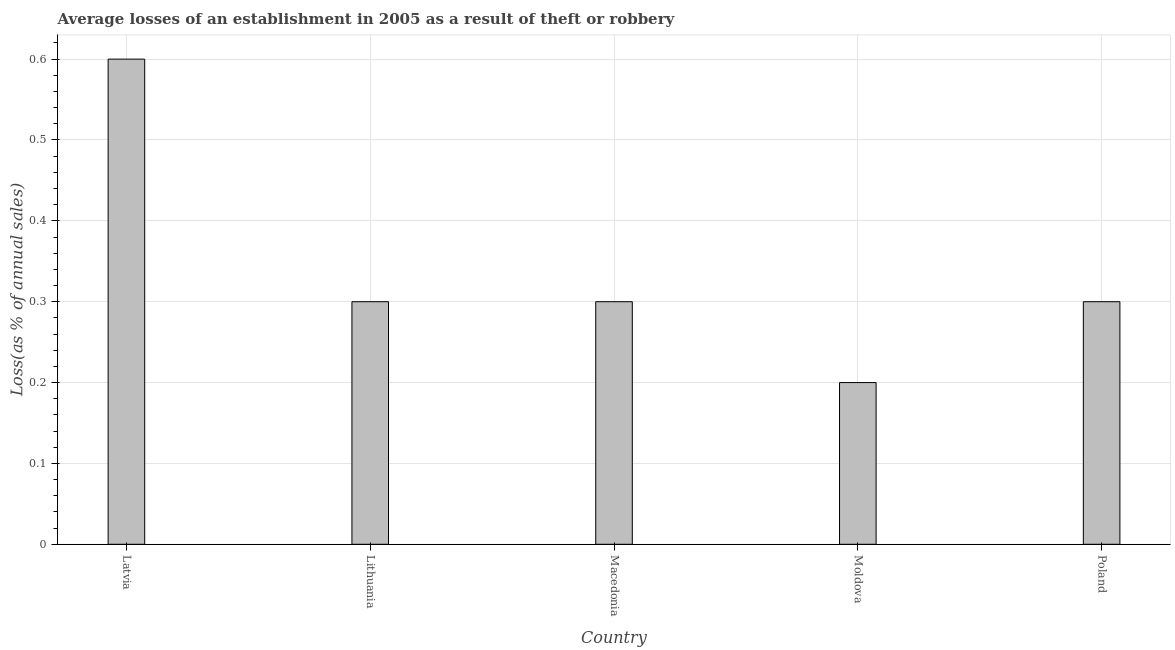Does the graph contain grids?
Your answer should be compact. Yes. What is the title of the graph?
Your response must be concise. Average losses of an establishment in 2005 as a result of theft or robbery. What is the label or title of the X-axis?
Your response must be concise. Country. What is the label or title of the Y-axis?
Offer a very short reply. Loss(as % of annual sales). Across all countries, what is the maximum losses due to theft?
Offer a terse response. 0.6. Across all countries, what is the minimum losses due to theft?
Your answer should be compact. 0.2. In which country was the losses due to theft maximum?
Make the answer very short. Latvia. In which country was the losses due to theft minimum?
Your answer should be very brief. Moldova. What is the average losses due to theft per country?
Offer a very short reply. 0.34. In how many countries, is the losses due to theft greater than 0.36 %?
Ensure brevity in your answer.  1. What is the ratio of the losses due to theft in Latvia to that in Moldova?
Ensure brevity in your answer.  3. What is the difference between the highest and the second highest losses due to theft?
Make the answer very short. 0.3. Is the sum of the losses due to theft in Latvia and Moldova greater than the maximum losses due to theft across all countries?
Give a very brief answer. Yes. What is the difference between the highest and the lowest losses due to theft?
Offer a very short reply. 0.4. In how many countries, is the losses due to theft greater than the average losses due to theft taken over all countries?
Offer a terse response. 1. Are all the bars in the graph horizontal?
Offer a terse response. No. How many countries are there in the graph?
Offer a very short reply. 5. What is the difference between two consecutive major ticks on the Y-axis?
Make the answer very short. 0.1. Are the values on the major ticks of Y-axis written in scientific E-notation?
Offer a very short reply. No. What is the Loss(as % of annual sales) of Moldova?
Offer a terse response. 0.2. What is the Loss(as % of annual sales) in Poland?
Your response must be concise. 0.3. What is the difference between the Loss(as % of annual sales) in Latvia and Lithuania?
Make the answer very short. 0.3. What is the difference between the Loss(as % of annual sales) in Latvia and Macedonia?
Offer a very short reply. 0.3. What is the difference between the Loss(as % of annual sales) in Latvia and Moldova?
Offer a terse response. 0.4. What is the difference between the Loss(as % of annual sales) in Latvia and Poland?
Your response must be concise. 0.3. What is the difference between the Loss(as % of annual sales) in Lithuania and Macedonia?
Your answer should be compact. 0. What is the difference between the Loss(as % of annual sales) in Lithuania and Poland?
Offer a terse response. 0. What is the difference between the Loss(as % of annual sales) in Moldova and Poland?
Offer a terse response. -0.1. What is the ratio of the Loss(as % of annual sales) in Latvia to that in Moldova?
Your response must be concise. 3. What is the ratio of the Loss(as % of annual sales) in Latvia to that in Poland?
Offer a terse response. 2. What is the ratio of the Loss(as % of annual sales) in Lithuania to that in Poland?
Your answer should be very brief. 1. What is the ratio of the Loss(as % of annual sales) in Macedonia to that in Moldova?
Make the answer very short. 1.5. What is the ratio of the Loss(as % of annual sales) in Macedonia to that in Poland?
Give a very brief answer. 1. What is the ratio of the Loss(as % of annual sales) in Moldova to that in Poland?
Your response must be concise. 0.67. 